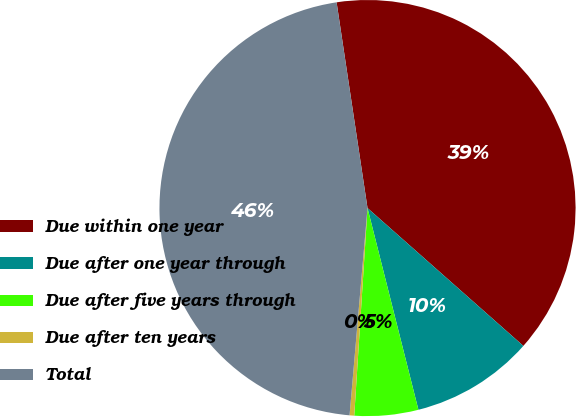<chart> <loc_0><loc_0><loc_500><loc_500><pie_chart><fcel>Due within one year<fcel>Due after one year through<fcel>Due after five years through<fcel>Due after ten years<fcel>Total<nl><fcel>38.9%<fcel>9.54%<fcel>4.95%<fcel>0.36%<fcel>46.25%<nl></chart> 